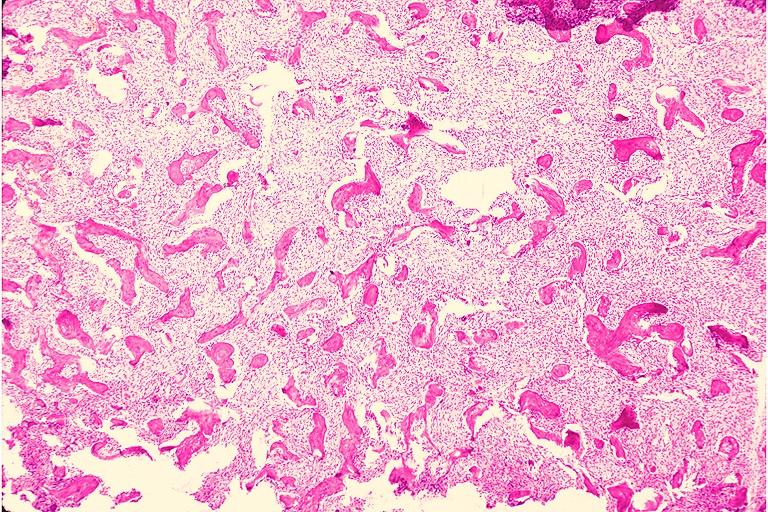does the lesion show fibrous dysplasia?
Answer the question using a single word or phrase. No 